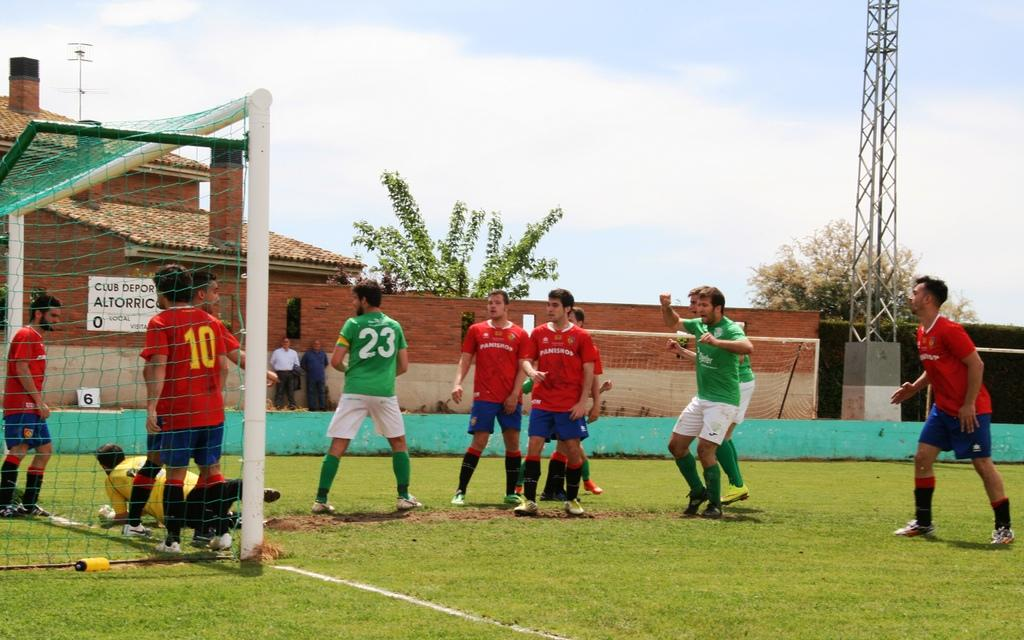<image>
Create a compact narrative representing the image presented. Club Depor Altorrico is a spot where young men play soccer. 